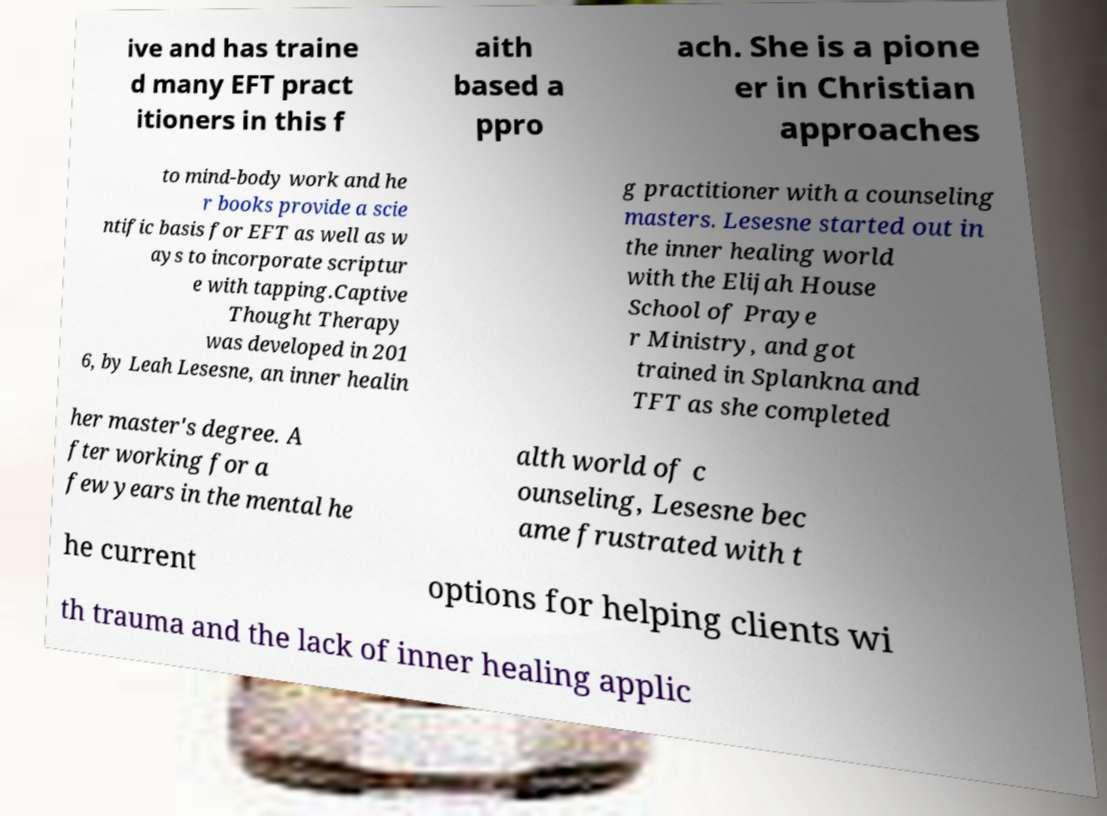What messages or text are displayed in this image? I need them in a readable, typed format. ive and has traine d many EFT pract itioners in this f aith based a ppro ach. She is a pione er in Christian approaches to mind-body work and he r books provide a scie ntific basis for EFT as well as w ays to incorporate scriptur e with tapping.Captive Thought Therapy was developed in 201 6, by Leah Lesesne, an inner healin g practitioner with a counseling masters. Lesesne started out in the inner healing world with the Elijah House School of Praye r Ministry, and got trained in Splankna and TFT as she completed her master's degree. A fter working for a few years in the mental he alth world of c ounseling, Lesesne bec ame frustrated with t he current options for helping clients wi th trauma and the lack of inner healing applic 